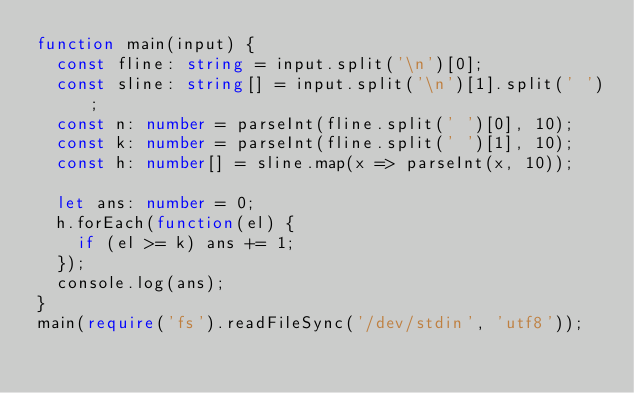Convert code to text. <code><loc_0><loc_0><loc_500><loc_500><_TypeScript_>function main(input) {
  const fline: string = input.split('\n')[0];
  const sline: string[] = input.split('\n')[1].split(' ');
  const n: number = parseInt(fline.split(' ')[0], 10);
  const k: number = parseInt(fline.split(' ')[1], 10);
  const h: number[] = sline.map(x => parseInt(x, 10));
  
  let ans: number = 0;
  h.forEach(function(el) {
    if (el >= k) ans += 1;
  });
  console.log(ans);
}
main(require('fs').readFileSync('/dev/stdin', 'utf8'));</code> 